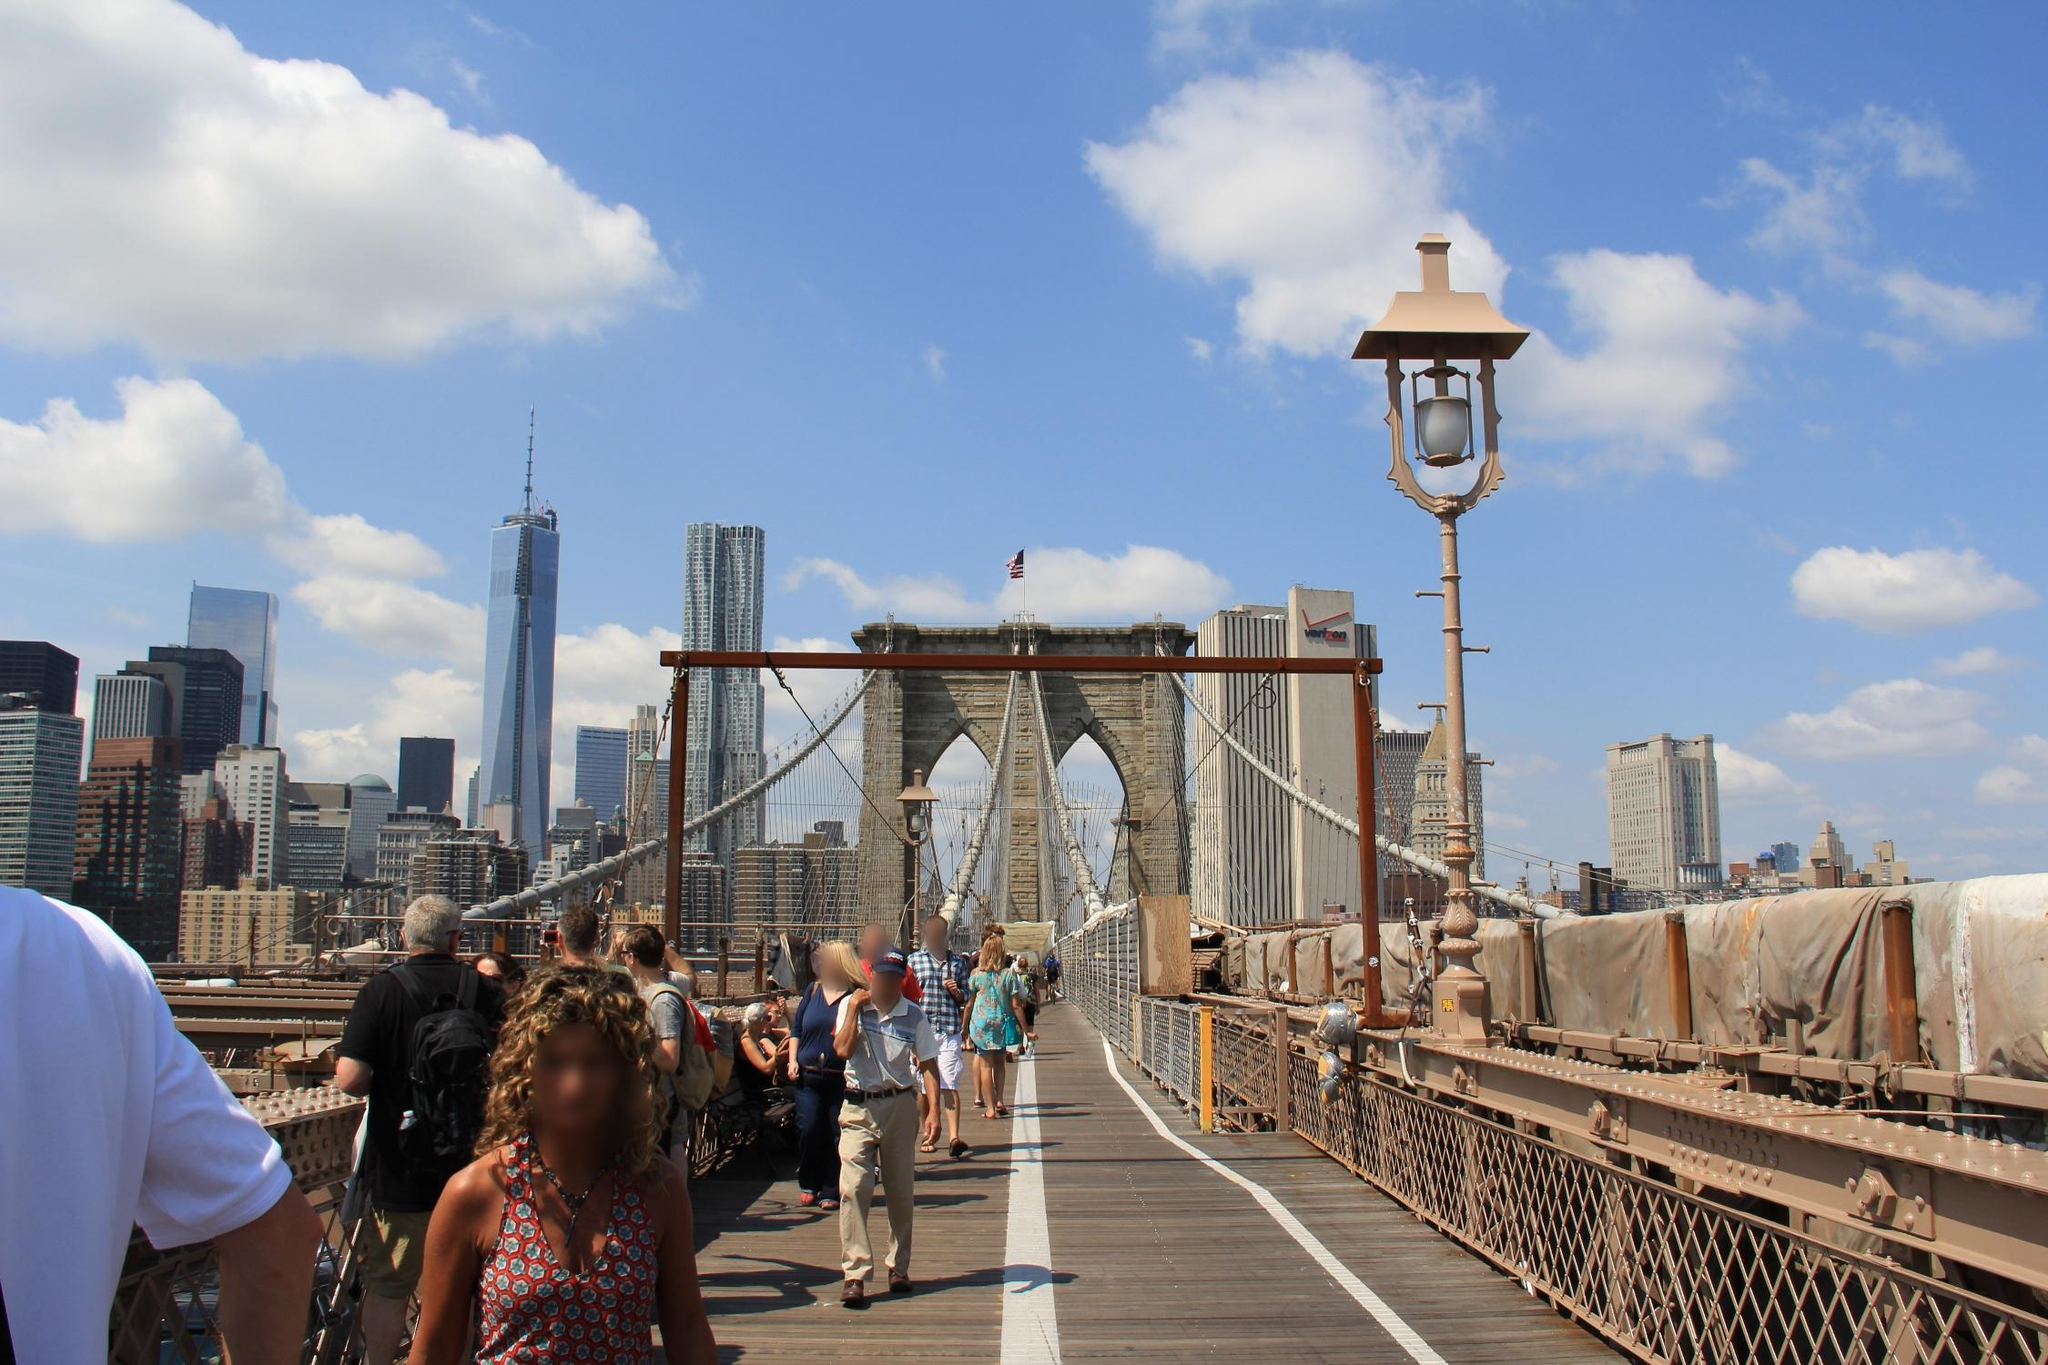Imagine the bridge comes to life as a character in a story. Describe its personality and interactions with the people. In a whimsical tale, the Brooklyn Bridge comes to life as Bricky, a wise and sturdy guardian of the river. Bricky stands tall and proud, always ready to greet visitors with a warm, welcoming presence. With a deep voice that echoes through its arches, Bricky shares ancient stories of the city’s history with those willing to listen. Bricky's cables hum with energy, creating a gentle, melodic tune that accompanies the footsteps of passersby. As the sun sets, Bricky's lampposts light up like twinkling eyes, guiding the way and offering comfort. Bricky takes great pride in connecting people and places, showing kindness to the weary traveler and curiosity to the inquisitive tourist. It engages in playful banter with the skyscrapers across the river, boasting about the countless memories and moments it has witnessed. Through storms and sunshine alike, Bricky remains a steadfast companion, a symbol of unity and strength in the heart of the city. 